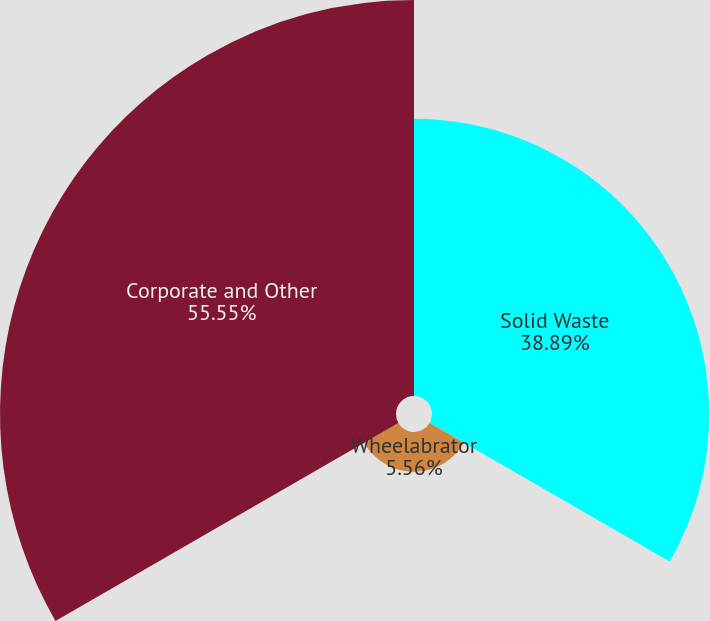<chart> <loc_0><loc_0><loc_500><loc_500><pie_chart><fcel>Solid Waste<fcel>Wheelabrator<fcel>Corporate and Other<nl><fcel>38.89%<fcel>5.56%<fcel>55.56%<nl></chart> 